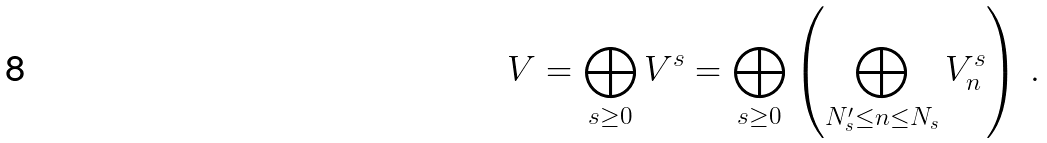<formula> <loc_0><loc_0><loc_500><loc_500>V = \bigoplus _ { s \geq 0 } V ^ { s } = \bigoplus _ { s \geq 0 } \left ( \bigoplus _ { N ^ { \prime } _ { s } \leq n \leq N _ { s } } V _ { n } ^ { s } \right ) \, .</formula> 